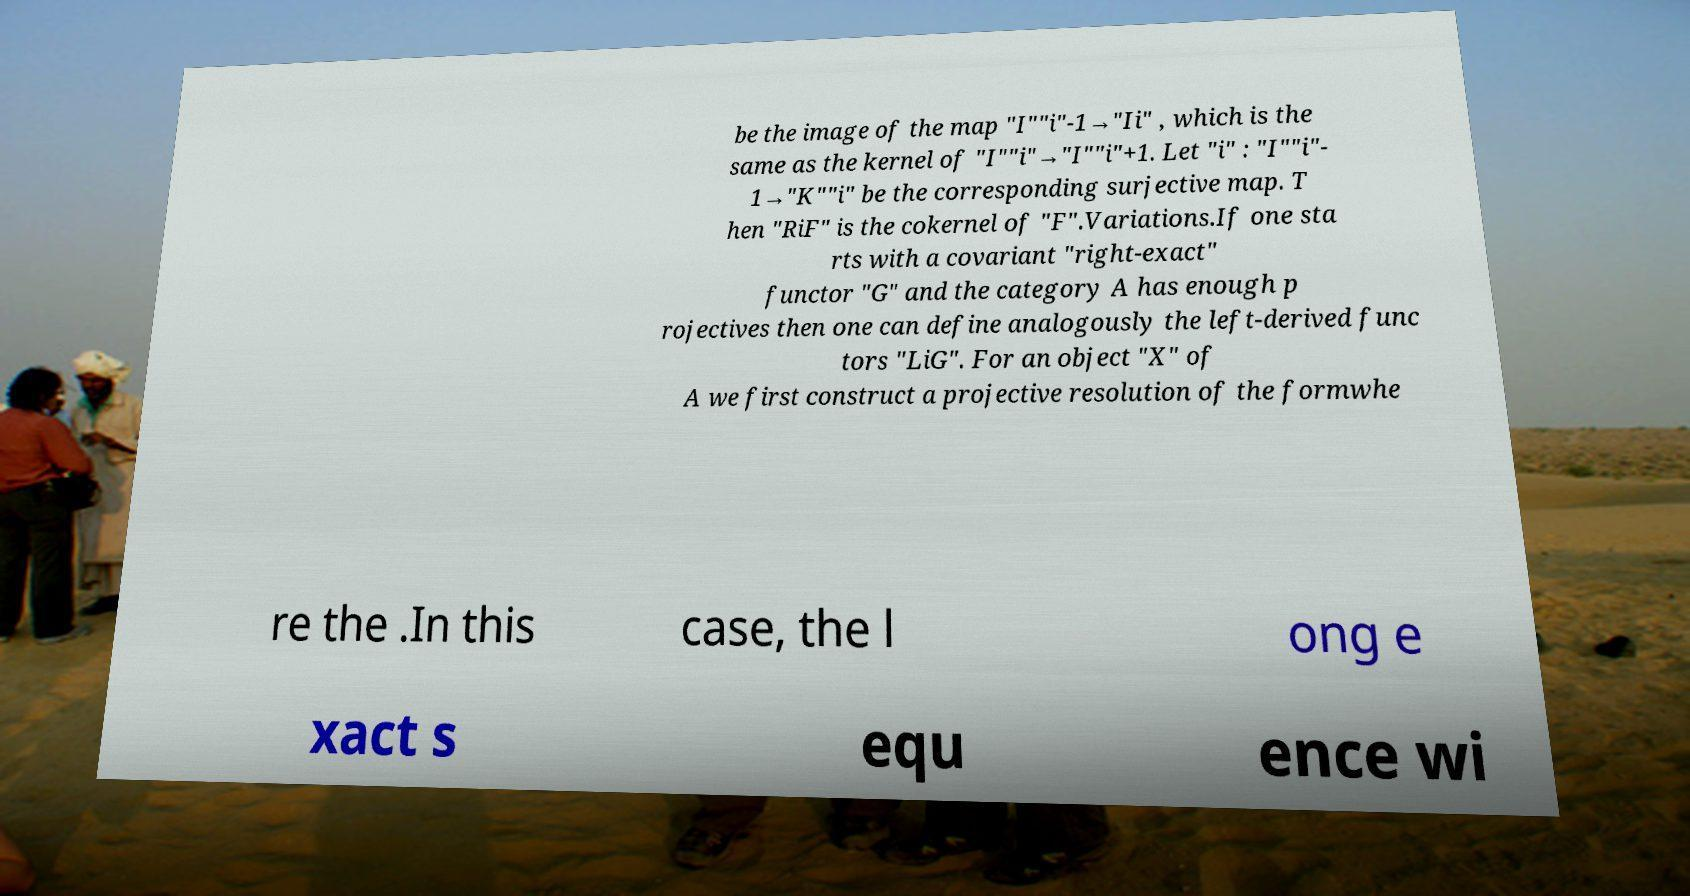I need the written content from this picture converted into text. Can you do that? be the image of the map "I""i"-1→"Ii" , which is the same as the kernel of "I""i"→"I""i"+1. Let "i" : "I""i"- 1→"K""i" be the corresponding surjective map. T hen "RiF" is the cokernel of "F".Variations.If one sta rts with a covariant "right-exact" functor "G" and the category A has enough p rojectives then one can define analogously the left-derived func tors "LiG". For an object "X" of A we first construct a projective resolution of the formwhe re the .In this case, the l ong e xact s equ ence wi 